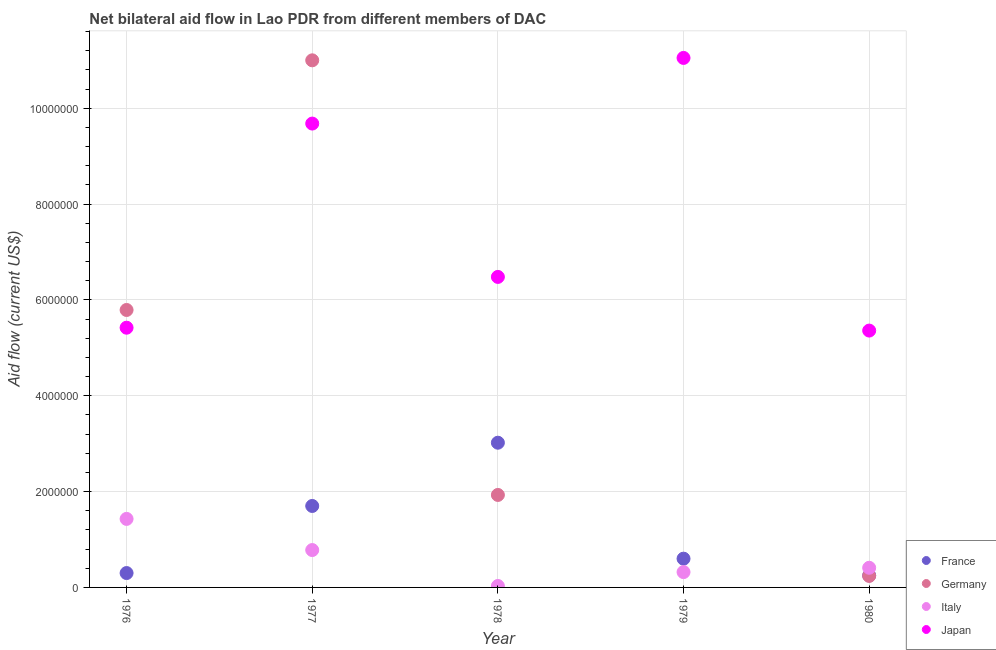How many different coloured dotlines are there?
Provide a short and direct response. 4. What is the amount of aid given by japan in 1979?
Provide a short and direct response. 1.10e+07. Across all years, what is the maximum amount of aid given by japan?
Provide a short and direct response. 1.10e+07. Across all years, what is the minimum amount of aid given by germany?
Provide a succinct answer. 0. What is the total amount of aid given by italy in the graph?
Keep it short and to the point. 2.97e+06. What is the difference between the amount of aid given by japan in 1976 and that in 1980?
Provide a succinct answer. 6.00e+04. What is the difference between the amount of aid given by france in 1980 and the amount of aid given by italy in 1977?
Your response must be concise. -5.30e+05. What is the average amount of aid given by france per year?
Provide a succinct answer. 1.17e+06. In the year 1976, what is the difference between the amount of aid given by italy and amount of aid given by japan?
Your response must be concise. -3.99e+06. In how many years, is the amount of aid given by italy greater than 3200000 US$?
Your answer should be compact. 0. What is the ratio of the amount of aid given by japan in 1978 to that in 1979?
Give a very brief answer. 0.59. Is the amount of aid given by germany in 1976 less than that in 1977?
Offer a very short reply. Yes. Is the difference between the amount of aid given by france in 1979 and 1980 greater than the difference between the amount of aid given by japan in 1979 and 1980?
Keep it short and to the point. No. What is the difference between the highest and the second highest amount of aid given by italy?
Your response must be concise. 6.50e+05. What is the difference between the highest and the lowest amount of aid given by japan?
Your answer should be compact. 5.69e+06. Is the sum of the amount of aid given by italy in 1976 and 1979 greater than the maximum amount of aid given by france across all years?
Your answer should be compact. No. Is it the case that in every year, the sum of the amount of aid given by germany and amount of aid given by japan is greater than the sum of amount of aid given by france and amount of aid given by italy?
Ensure brevity in your answer.  No. Is the amount of aid given by germany strictly greater than the amount of aid given by france over the years?
Your answer should be very brief. No. What is the difference between two consecutive major ticks on the Y-axis?
Your answer should be compact. 2.00e+06. Does the graph contain any zero values?
Offer a very short reply. Yes. How many legend labels are there?
Make the answer very short. 4. How are the legend labels stacked?
Give a very brief answer. Vertical. What is the title of the graph?
Give a very brief answer. Net bilateral aid flow in Lao PDR from different members of DAC. What is the Aid flow (current US$) of France in 1976?
Your answer should be very brief. 3.00e+05. What is the Aid flow (current US$) of Germany in 1976?
Provide a succinct answer. 5.79e+06. What is the Aid flow (current US$) in Italy in 1976?
Ensure brevity in your answer.  1.43e+06. What is the Aid flow (current US$) in Japan in 1976?
Ensure brevity in your answer.  5.42e+06. What is the Aid flow (current US$) in France in 1977?
Keep it short and to the point. 1.70e+06. What is the Aid flow (current US$) of Germany in 1977?
Your response must be concise. 1.10e+07. What is the Aid flow (current US$) of Italy in 1977?
Your answer should be compact. 7.80e+05. What is the Aid flow (current US$) in Japan in 1977?
Provide a succinct answer. 9.68e+06. What is the Aid flow (current US$) in France in 1978?
Your answer should be compact. 3.02e+06. What is the Aid flow (current US$) in Germany in 1978?
Ensure brevity in your answer.  1.93e+06. What is the Aid flow (current US$) of Italy in 1978?
Your answer should be very brief. 3.00e+04. What is the Aid flow (current US$) of Japan in 1978?
Offer a terse response. 6.48e+06. What is the Aid flow (current US$) in Germany in 1979?
Provide a short and direct response. 0. What is the Aid flow (current US$) in Italy in 1979?
Offer a very short reply. 3.20e+05. What is the Aid flow (current US$) in Japan in 1979?
Keep it short and to the point. 1.10e+07. What is the Aid flow (current US$) of France in 1980?
Give a very brief answer. 2.50e+05. What is the Aid flow (current US$) in Italy in 1980?
Provide a succinct answer. 4.10e+05. What is the Aid flow (current US$) in Japan in 1980?
Give a very brief answer. 5.36e+06. Across all years, what is the maximum Aid flow (current US$) in France?
Your answer should be compact. 3.02e+06. Across all years, what is the maximum Aid flow (current US$) of Germany?
Make the answer very short. 1.10e+07. Across all years, what is the maximum Aid flow (current US$) of Italy?
Your answer should be very brief. 1.43e+06. Across all years, what is the maximum Aid flow (current US$) of Japan?
Make the answer very short. 1.10e+07. Across all years, what is the minimum Aid flow (current US$) of Germany?
Offer a very short reply. 0. Across all years, what is the minimum Aid flow (current US$) in Italy?
Provide a short and direct response. 3.00e+04. Across all years, what is the minimum Aid flow (current US$) in Japan?
Your response must be concise. 5.36e+06. What is the total Aid flow (current US$) of France in the graph?
Keep it short and to the point. 5.87e+06. What is the total Aid flow (current US$) of Germany in the graph?
Your answer should be compact. 1.90e+07. What is the total Aid flow (current US$) in Italy in the graph?
Your answer should be very brief. 2.97e+06. What is the total Aid flow (current US$) in Japan in the graph?
Offer a terse response. 3.80e+07. What is the difference between the Aid flow (current US$) in France in 1976 and that in 1977?
Offer a very short reply. -1.40e+06. What is the difference between the Aid flow (current US$) of Germany in 1976 and that in 1977?
Your answer should be compact. -5.21e+06. What is the difference between the Aid flow (current US$) in Italy in 1976 and that in 1977?
Give a very brief answer. 6.50e+05. What is the difference between the Aid flow (current US$) in Japan in 1976 and that in 1977?
Ensure brevity in your answer.  -4.26e+06. What is the difference between the Aid flow (current US$) in France in 1976 and that in 1978?
Provide a short and direct response. -2.72e+06. What is the difference between the Aid flow (current US$) in Germany in 1976 and that in 1978?
Your answer should be compact. 3.86e+06. What is the difference between the Aid flow (current US$) of Italy in 1976 and that in 1978?
Your answer should be very brief. 1.40e+06. What is the difference between the Aid flow (current US$) of Japan in 1976 and that in 1978?
Offer a terse response. -1.06e+06. What is the difference between the Aid flow (current US$) in Italy in 1976 and that in 1979?
Offer a terse response. 1.11e+06. What is the difference between the Aid flow (current US$) in Japan in 1976 and that in 1979?
Your answer should be very brief. -5.63e+06. What is the difference between the Aid flow (current US$) in France in 1976 and that in 1980?
Offer a very short reply. 5.00e+04. What is the difference between the Aid flow (current US$) of Germany in 1976 and that in 1980?
Offer a terse response. 5.55e+06. What is the difference between the Aid flow (current US$) of Italy in 1976 and that in 1980?
Provide a short and direct response. 1.02e+06. What is the difference between the Aid flow (current US$) in Japan in 1976 and that in 1980?
Your answer should be compact. 6.00e+04. What is the difference between the Aid flow (current US$) in France in 1977 and that in 1978?
Provide a short and direct response. -1.32e+06. What is the difference between the Aid flow (current US$) in Germany in 1977 and that in 1978?
Keep it short and to the point. 9.07e+06. What is the difference between the Aid flow (current US$) in Italy in 1977 and that in 1978?
Make the answer very short. 7.50e+05. What is the difference between the Aid flow (current US$) of Japan in 1977 and that in 1978?
Your answer should be compact. 3.20e+06. What is the difference between the Aid flow (current US$) of France in 1977 and that in 1979?
Offer a very short reply. 1.10e+06. What is the difference between the Aid flow (current US$) in Japan in 1977 and that in 1979?
Your response must be concise. -1.37e+06. What is the difference between the Aid flow (current US$) in France in 1977 and that in 1980?
Give a very brief answer. 1.45e+06. What is the difference between the Aid flow (current US$) in Germany in 1977 and that in 1980?
Provide a succinct answer. 1.08e+07. What is the difference between the Aid flow (current US$) in Japan in 1977 and that in 1980?
Give a very brief answer. 4.32e+06. What is the difference between the Aid flow (current US$) in France in 1978 and that in 1979?
Offer a very short reply. 2.42e+06. What is the difference between the Aid flow (current US$) in Japan in 1978 and that in 1979?
Offer a very short reply. -4.57e+06. What is the difference between the Aid flow (current US$) in France in 1978 and that in 1980?
Provide a succinct answer. 2.77e+06. What is the difference between the Aid flow (current US$) in Germany in 1978 and that in 1980?
Keep it short and to the point. 1.69e+06. What is the difference between the Aid flow (current US$) in Italy in 1978 and that in 1980?
Offer a terse response. -3.80e+05. What is the difference between the Aid flow (current US$) in Japan in 1978 and that in 1980?
Your answer should be very brief. 1.12e+06. What is the difference between the Aid flow (current US$) of France in 1979 and that in 1980?
Your answer should be very brief. 3.50e+05. What is the difference between the Aid flow (current US$) in Japan in 1979 and that in 1980?
Your answer should be compact. 5.69e+06. What is the difference between the Aid flow (current US$) of France in 1976 and the Aid flow (current US$) of Germany in 1977?
Provide a short and direct response. -1.07e+07. What is the difference between the Aid flow (current US$) of France in 1976 and the Aid flow (current US$) of Italy in 1977?
Make the answer very short. -4.80e+05. What is the difference between the Aid flow (current US$) of France in 1976 and the Aid flow (current US$) of Japan in 1977?
Your response must be concise. -9.38e+06. What is the difference between the Aid flow (current US$) in Germany in 1976 and the Aid flow (current US$) in Italy in 1977?
Your answer should be very brief. 5.01e+06. What is the difference between the Aid flow (current US$) of Germany in 1976 and the Aid flow (current US$) of Japan in 1977?
Give a very brief answer. -3.89e+06. What is the difference between the Aid flow (current US$) of Italy in 1976 and the Aid flow (current US$) of Japan in 1977?
Offer a terse response. -8.25e+06. What is the difference between the Aid flow (current US$) of France in 1976 and the Aid flow (current US$) of Germany in 1978?
Your response must be concise. -1.63e+06. What is the difference between the Aid flow (current US$) in France in 1976 and the Aid flow (current US$) in Italy in 1978?
Make the answer very short. 2.70e+05. What is the difference between the Aid flow (current US$) of France in 1976 and the Aid flow (current US$) of Japan in 1978?
Make the answer very short. -6.18e+06. What is the difference between the Aid flow (current US$) of Germany in 1976 and the Aid flow (current US$) of Italy in 1978?
Offer a very short reply. 5.76e+06. What is the difference between the Aid flow (current US$) of Germany in 1976 and the Aid flow (current US$) of Japan in 1978?
Offer a terse response. -6.90e+05. What is the difference between the Aid flow (current US$) of Italy in 1976 and the Aid flow (current US$) of Japan in 1978?
Provide a short and direct response. -5.05e+06. What is the difference between the Aid flow (current US$) of France in 1976 and the Aid flow (current US$) of Japan in 1979?
Keep it short and to the point. -1.08e+07. What is the difference between the Aid flow (current US$) in Germany in 1976 and the Aid flow (current US$) in Italy in 1979?
Keep it short and to the point. 5.47e+06. What is the difference between the Aid flow (current US$) in Germany in 1976 and the Aid flow (current US$) in Japan in 1979?
Keep it short and to the point. -5.26e+06. What is the difference between the Aid flow (current US$) in Italy in 1976 and the Aid flow (current US$) in Japan in 1979?
Ensure brevity in your answer.  -9.62e+06. What is the difference between the Aid flow (current US$) in France in 1976 and the Aid flow (current US$) in Italy in 1980?
Make the answer very short. -1.10e+05. What is the difference between the Aid flow (current US$) in France in 1976 and the Aid flow (current US$) in Japan in 1980?
Give a very brief answer. -5.06e+06. What is the difference between the Aid flow (current US$) of Germany in 1976 and the Aid flow (current US$) of Italy in 1980?
Offer a terse response. 5.38e+06. What is the difference between the Aid flow (current US$) of Germany in 1976 and the Aid flow (current US$) of Japan in 1980?
Offer a very short reply. 4.30e+05. What is the difference between the Aid flow (current US$) in Italy in 1976 and the Aid flow (current US$) in Japan in 1980?
Your response must be concise. -3.93e+06. What is the difference between the Aid flow (current US$) in France in 1977 and the Aid flow (current US$) in Italy in 1978?
Your answer should be compact. 1.67e+06. What is the difference between the Aid flow (current US$) in France in 1977 and the Aid flow (current US$) in Japan in 1978?
Give a very brief answer. -4.78e+06. What is the difference between the Aid flow (current US$) in Germany in 1977 and the Aid flow (current US$) in Italy in 1978?
Offer a very short reply. 1.10e+07. What is the difference between the Aid flow (current US$) in Germany in 1977 and the Aid flow (current US$) in Japan in 1978?
Your answer should be compact. 4.52e+06. What is the difference between the Aid flow (current US$) in Italy in 1977 and the Aid flow (current US$) in Japan in 1978?
Offer a terse response. -5.70e+06. What is the difference between the Aid flow (current US$) in France in 1977 and the Aid flow (current US$) in Italy in 1979?
Provide a succinct answer. 1.38e+06. What is the difference between the Aid flow (current US$) of France in 1977 and the Aid flow (current US$) of Japan in 1979?
Offer a very short reply. -9.35e+06. What is the difference between the Aid flow (current US$) of Germany in 1977 and the Aid flow (current US$) of Italy in 1979?
Keep it short and to the point. 1.07e+07. What is the difference between the Aid flow (current US$) of Italy in 1977 and the Aid flow (current US$) of Japan in 1979?
Make the answer very short. -1.03e+07. What is the difference between the Aid flow (current US$) of France in 1977 and the Aid flow (current US$) of Germany in 1980?
Make the answer very short. 1.46e+06. What is the difference between the Aid flow (current US$) in France in 1977 and the Aid flow (current US$) in Italy in 1980?
Ensure brevity in your answer.  1.29e+06. What is the difference between the Aid flow (current US$) of France in 1977 and the Aid flow (current US$) of Japan in 1980?
Offer a very short reply. -3.66e+06. What is the difference between the Aid flow (current US$) of Germany in 1977 and the Aid flow (current US$) of Italy in 1980?
Offer a terse response. 1.06e+07. What is the difference between the Aid flow (current US$) in Germany in 1977 and the Aid flow (current US$) in Japan in 1980?
Give a very brief answer. 5.64e+06. What is the difference between the Aid flow (current US$) of Italy in 1977 and the Aid flow (current US$) of Japan in 1980?
Provide a succinct answer. -4.58e+06. What is the difference between the Aid flow (current US$) in France in 1978 and the Aid flow (current US$) in Italy in 1979?
Offer a very short reply. 2.70e+06. What is the difference between the Aid flow (current US$) in France in 1978 and the Aid flow (current US$) in Japan in 1979?
Keep it short and to the point. -8.03e+06. What is the difference between the Aid flow (current US$) of Germany in 1978 and the Aid flow (current US$) of Italy in 1979?
Your answer should be very brief. 1.61e+06. What is the difference between the Aid flow (current US$) in Germany in 1978 and the Aid flow (current US$) in Japan in 1979?
Your response must be concise. -9.12e+06. What is the difference between the Aid flow (current US$) in Italy in 1978 and the Aid flow (current US$) in Japan in 1979?
Your answer should be very brief. -1.10e+07. What is the difference between the Aid flow (current US$) of France in 1978 and the Aid flow (current US$) of Germany in 1980?
Ensure brevity in your answer.  2.78e+06. What is the difference between the Aid flow (current US$) of France in 1978 and the Aid flow (current US$) of Italy in 1980?
Provide a short and direct response. 2.61e+06. What is the difference between the Aid flow (current US$) of France in 1978 and the Aid flow (current US$) of Japan in 1980?
Give a very brief answer. -2.34e+06. What is the difference between the Aid flow (current US$) in Germany in 1978 and the Aid flow (current US$) in Italy in 1980?
Provide a short and direct response. 1.52e+06. What is the difference between the Aid flow (current US$) of Germany in 1978 and the Aid flow (current US$) of Japan in 1980?
Offer a terse response. -3.43e+06. What is the difference between the Aid flow (current US$) in Italy in 1978 and the Aid flow (current US$) in Japan in 1980?
Provide a succinct answer. -5.33e+06. What is the difference between the Aid flow (current US$) of France in 1979 and the Aid flow (current US$) of Germany in 1980?
Give a very brief answer. 3.60e+05. What is the difference between the Aid flow (current US$) of France in 1979 and the Aid flow (current US$) of Italy in 1980?
Provide a succinct answer. 1.90e+05. What is the difference between the Aid flow (current US$) of France in 1979 and the Aid flow (current US$) of Japan in 1980?
Your response must be concise. -4.76e+06. What is the difference between the Aid flow (current US$) of Italy in 1979 and the Aid flow (current US$) of Japan in 1980?
Your answer should be compact. -5.04e+06. What is the average Aid flow (current US$) of France per year?
Offer a terse response. 1.17e+06. What is the average Aid flow (current US$) of Germany per year?
Keep it short and to the point. 3.79e+06. What is the average Aid flow (current US$) in Italy per year?
Provide a succinct answer. 5.94e+05. What is the average Aid flow (current US$) in Japan per year?
Your response must be concise. 7.60e+06. In the year 1976, what is the difference between the Aid flow (current US$) in France and Aid flow (current US$) in Germany?
Offer a terse response. -5.49e+06. In the year 1976, what is the difference between the Aid flow (current US$) of France and Aid flow (current US$) of Italy?
Provide a short and direct response. -1.13e+06. In the year 1976, what is the difference between the Aid flow (current US$) of France and Aid flow (current US$) of Japan?
Keep it short and to the point. -5.12e+06. In the year 1976, what is the difference between the Aid flow (current US$) in Germany and Aid flow (current US$) in Italy?
Offer a terse response. 4.36e+06. In the year 1976, what is the difference between the Aid flow (current US$) in Germany and Aid flow (current US$) in Japan?
Your response must be concise. 3.70e+05. In the year 1976, what is the difference between the Aid flow (current US$) in Italy and Aid flow (current US$) in Japan?
Your answer should be compact. -3.99e+06. In the year 1977, what is the difference between the Aid flow (current US$) of France and Aid flow (current US$) of Germany?
Keep it short and to the point. -9.30e+06. In the year 1977, what is the difference between the Aid flow (current US$) of France and Aid flow (current US$) of Italy?
Give a very brief answer. 9.20e+05. In the year 1977, what is the difference between the Aid flow (current US$) in France and Aid flow (current US$) in Japan?
Provide a short and direct response. -7.98e+06. In the year 1977, what is the difference between the Aid flow (current US$) of Germany and Aid flow (current US$) of Italy?
Ensure brevity in your answer.  1.02e+07. In the year 1977, what is the difference between the Aid flow (current US$) of Germany and Aid flow (current US$) of Japan?
Your answer should be compact. 1.32e+06. In the year 1977, what is the difference between the Aid flow (current US$) in Italy and Aid flow (current US$) in Japan?
Your response must be concise. -8.90e+06. In the year 1978, what is the difference between the Aid flow (current US$) in France and Aid flow (current US$) in Germany?
Make the answer very short. 1.09e+06. In the year 1978, what is the difference between the Aid flow (current US$) of France and Aid flow (current US$) of Italy?
Offer a terse response. 2.99e+06. In the year 1978, what is the difference between the Aid flow (current US$) of France and Aid flow (current US$) of Japan?
Your answer should be very brief. -3.46e+06. In the year 1978, what is the difference between the Aid flow (current US$) in Germany and Aid flow (current US$) in Italy?
Your answer should be very brief. 1.90e+06. In the year 1978, what is the difference between the Aid flow (current US$) of Germany and Aid flow (current US$) of Japan?
Give a very brief answer. -4.55e+06. In the year 1978, what is the difference between the Aid flow (current US$) in Italy and Aid flow (current US$) in Japan?
Give a very brief answer. -6.45e+06. In the year 1979, what is the difference between the Aid flow (current US$) of France and Aid flow (current US$) of Italy?
Your response must be concise. 2.80e+05. In the year 1979, what is the difference between the Aid flow (current US$) in France and Aid flow (current US$) in Japan?
Keep it short and to the point. -1.04e+07. In the year 1979, what is the difference between the Aid flow (current US$) of Italy and Aid flow (current US$) of Japan?
Your response must be concise. -1.07e+07. In the year 1980, what is the difference between the Aid flow (current US$) of France and Aid flow (current US$) of Japan?
Give a very brief answer. -5.11e+06. In the year 1980, what is the difference between the Aid flow (current US$) of Germany and Aid flow (current US$) of Italy?
Offer a very short reply. -1.70e+05. In the year 1980, what is the difference between the Aid flow (current US$) of Germany and Aid flow (current US$) of Japan?
Offer a terse response. -5.12e+06. In the year 1980, what is the difference between the Aid flow (current US$) in Italy and Aid flow (current US$) in Japan?
Offer a terse response. -4.95e+06. What is the ratio of the Aid flow (current US$) in France in 1976 to that in 1977?
Your response must be concise. 0.18. What is the ratio of the Aid flow (current US$) in Germany in 1976 to that in 1977?
Your answer should be compact. 0.53. What is the ratio of the Aid flow (current US$) in Italy in 1976 to that in 1977?
Make the answer very short. 1.83. What is the ratio of the Aid flow (current US$) in Japan in 1976 to that in 1977?
Your answer should be very brief. 0.56. What is the ratio of the Aid flow (current US$) of France in 1976 to that in 1978?
Make the answer very short. 0.1. What is the ratio of the Aid flow (current US$) of Germany in 1976 to that in 1978?
Your answer should be compact. 3. What is the ratio of the Aid flow (current US$) of Italy in 1976 to that in 1978?
Provide a succinct answer. 47.67. What is the ratio of the Aid flow (current US$) of Japan in 1976 to that in 1978?
Your answer should be very brief. 0.84. What is the ratio of the Aid flow (current US$) of France in 1976 to that in 1979?
Make the answer very short. 0.5. What is the ratio of the Aid flow (current US$) of Italy in 1976 to that in 1979?
Keep it short and to the point. 4.47. What is the ratio of the Aid flow (current US$) in Japan in 1976 to that in 1979?
Give a very brief answer. 0.49. What is the ratio of the Aid flow (current US$) in France in 1976 to that in 1980?
Offer a terse response. 1.2. What is the ratio of the Aid flow (current US$) in Germany in 1976 to that in 1980?
Give a very brief answer. 24.12. What is the ratio of the Aid flow (current US$) of Italy in 1976 to that in 1980?
Keep it short and to the point. 3.49. What is the ratio of the Aid flow (current US$) of Japan in 1976 to that in 1980?
Provide a short and direct response. 1.01. What is the ratio of the Aid flow (current US$) of France in 1977 to that in 1978?
Offer a very short reply. 0.56. What is the ratio of the Aid flow (current US$) of Germany in 1977 to that in 1978?
Provide a short and direct response. 5.7. What is the ratio of the Aid flow (current US$) of Italy in 1977 to that in 1978?
Give a very brief answer. 26. What is the ratio of the Aid flow (current US$) in Japan in 1977 to that in 1978?
Offer a very short reply. 1.49. What is the ratio of the Aid flow (current US$) in France in 1977 to that in 1979?
Your answer should be very brief. 2.83. What is the ratio of the Aid flow (current US$) in Italy in 1977 to that in 1979?
Ensure brevity in your answer.  2.44. What is the ratio of the Aid flow (current US$) of Japan in 1977 to that in 1979?
Offer a terse response. 0.88. What is the ratio of the Aid flow (current US$) in Germany in 1977 to that in 1980?
Give a very brief answer. 45.83. What is the ratio of the Aid flow (current US$) in Italy in 1977 to that in 1980?
Keep it short and to the point. 1.9. What is the ratio of the Aid flow (current US$) of Japan in 1977 to that in 1980?
Provide a succinct answer. 1.81. What is the ratio of the Aid flow (current US$) of France in 1978 to that in 1979?
Your answer should be compact. 5.03. What is the ratio of the Aid flow (current US$) of Italy in 1978 to that in 1979?
Offer a terse response. 0.09. What is the ratio of the Aid flow (current US$) in Japan in 1978 to that in 1979?
Provide a short and direct response. 0.59. What is the ratio of the Aid flow (current US$) of France in 1978 to that in 1980?
Provide a short and direct response. 12.08. What is the ratio of the Aid flow (current US$) of Germany in 1978 to that in 1980?
Give a very brief answer. 8.04. What is the ratio of the Aid flow (current US$) in Italy in 1978 to that in 1980?
Provide a short and direct response. 0.07. What is the ratio of the Aid flow (current US$) in Japan in 1978 to that in 1980?
Your response must be concise. 1.21. What is the ratio of the Aid flow (current US$) of Italy in 1979 to that in 1980?
Your response must be concise. 0.78. What is the ratio of the Aid flow (current US$) of Japan in 1979 to that in 1980?
Provide a short and direct response. 2.06. What is the difference between the highest and the second highest Aid flow (current US$) in France?
Offer a terse response. 1.32e+06. What is the difference between the highest and the second highest Aid flow (current US$) of Germany?
Offer a terse response. 5.21e+06. What is the difference between the highest and the second highest Aid flow (current US$) of Italy?
Ensure brevity in your answer.  6.50e+05. What is the difference between the highest and the second highest Aid flow (current US$) in Japan?
Give a very brief answer. 1.37e+06. What is the difference between the highest and the lowest Aid flow (current US$) in France?
Offer a very short reply. 2.77e+06. What is the difference between the highest and the lowest Aid flow (current US$) of Germany?
Offer a terse response. 1.10e+07. What is the difference between the highest and the lowest Aid flow (current US$) of Italy?
Offer a very short reply. 1.40e+06. What is the difference between the highest and the lowest Aid flow (current US$) of Japan?
Your response must be concise. 5.69e+06. 